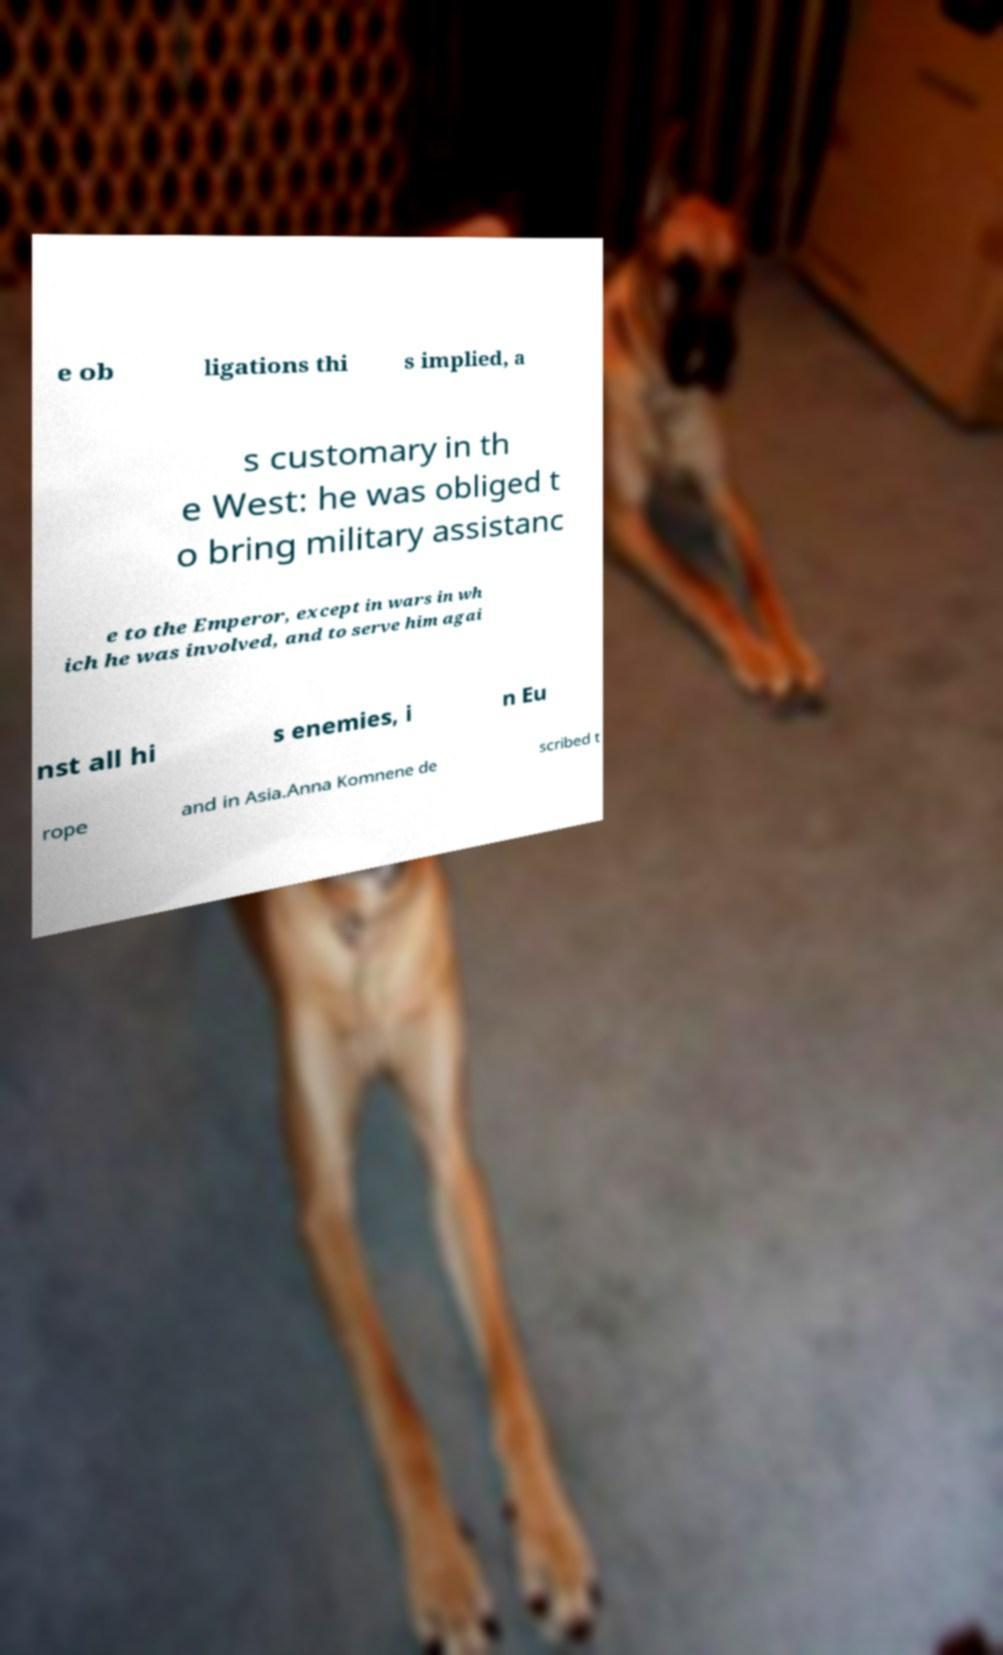For documentation purposes, I need the text within this image transcribed. Could you provide that? e ob ligations thi s implied, a s customary in th e West: he was obliged t o bring military assistanc e to the Emperor, except in wars in wh ich he was involved, and to serve him agai nst all hi s enemies, i n Eu rope and in Asia.Anna Komnene de scribed t 